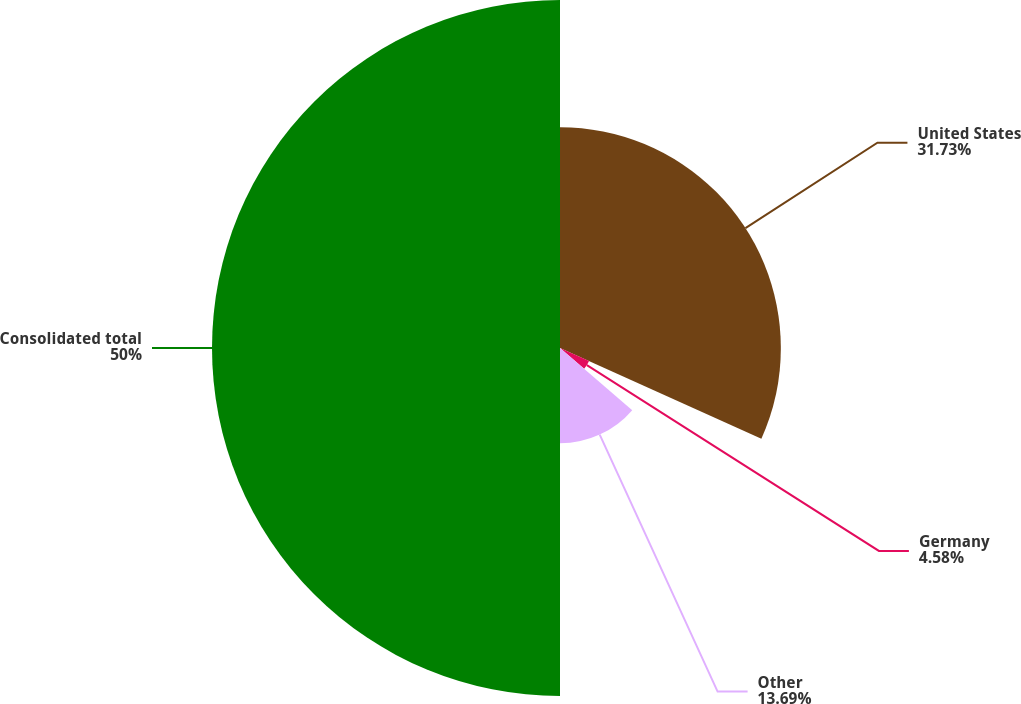Convert chart to OTSL. <chart><loc_0><loc_0><loc_500><loc_500><pie_chart><fcel>United States<fcel>Germany<fcel>Other<fcel>Consolidated total<nl><fcel>31.73%<fcel>4.58%<fcel>13.69%<fcel>50.0%<nl></chart> 